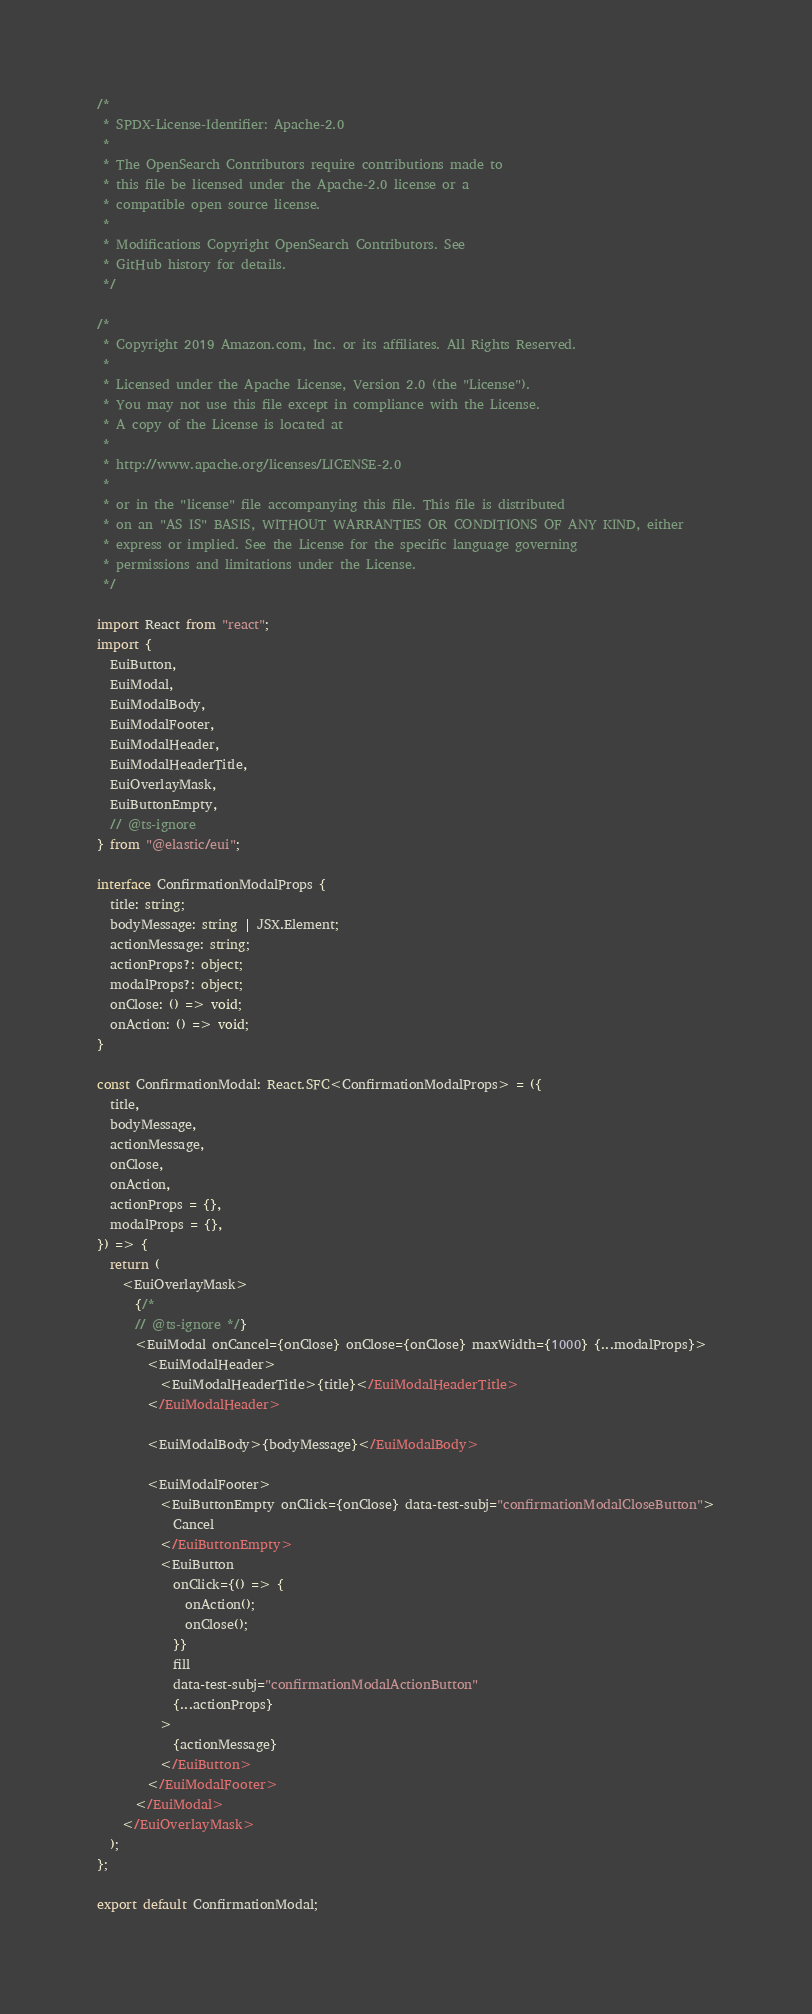Convert code to text. <code><loc_0><loc_0><loc_500><loc_500><_TypeScript_>/*
 * SPDX-License-Identifier: Apache-2.0
 *
 * The OpenSearch Contributors require contributions made to
 * this file be licensed under the Apache-2.0 license or a
 * compatible open source license.
 *
 * Modifications Copyright OpenSearch Contributors. See
 * GitHub history for details.
 */

/*
 * Copyright 2019 Amazon.com, Inc. or its affiliates. All Rights Reserved.
 *
 * Licensed under the Apache License, Version 2.0 (the "License").
 * You may not use this file except in compliance with the License.
 * A copy of the License is located at
 *
 * http://www.apache.org/licenses/LICENSE-2.0
 *
 * or in the "license" file accompanying this file. This file is distributed
 * on an "AS IS" BASIS, WITHOUT WARRANTIES OR CONDITIONS OF ANY KIND, either
 * express or implied. See the License for the specific language governing
 * permissions and limitations under the License.
 */

import React from "react";
import {
  EuiButton,
  EuiModal,
  EuiModalBody,
  EuiModalFooter,
  EuiModalHeader,
  EuiModalHeaderTitle,
  EuiOverlayMask,
  EuiButtonEmpty,
  // @ts-ignore
} from "@elastic/eui";

interface ConfirmationModalProps {
  title: string;
  bodyMessage: string | JSX.Element;
  actionMessage: string;
  actionProps?: object;
  modalProps?: object;
  onClose: () => void;
  onAction: () => void;
}

const ConfirmationModal: React.SFC<ConfirmationModalProps> = ({
  title,
  bodyMessage,
  actionMessage,
  onClose,
  onAction,
  actionProps = {},
  modalProps = {},
}) => {
  return (
    <EuiOverlayMask>
      {/*
      // @ts-ignore */}
      <EuiModal onCancel={onClose} onClose={onClose} maxWidth={1000} {...modalProps}>
        <EuiModalHeader>
          <EuiModalHeaderTitle>{title}</EuiModalHeaderTitle>
        </EuiModalHeader>

        <EuiModalBody>{bodyMessage}</EuiModalBody>

        <EuiModalFooter>
          <EuiButtonEmpty onClick={onClose} data-test-subj="confirmationModalCloseButton">
            Cancel
          </EuiButtonEmpty>
          <EuiButton
            onClick={() => {
              onAction();
              onClose();
            }}
            fill
            data-test-subj="confirmationModalActionButton"
            {...actionProps}
          >
            {actionMessage}
          </EuiButton>
        </EuiModalFooter>
      </EuiModal>
    </EuiOverlayMask>
  );
};

export default ConfirmationModal;
</code> 